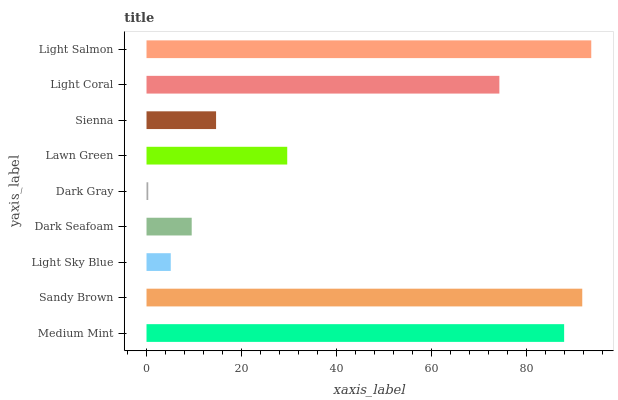Is Dark Gray the minimum?
Answer yes or no. Yes. Is Light Salmon the maximum?
Answer yes or no. Yes. Is Sandy Brown the minimum?
Answer yes or no. No. Is Sandy Brown the maximum?
Answer yes or no. No. Is Sandy Brown greater than Medium Mint?
Answer yes or no. Yes. Is Medium Mint less than Sandy Brown?
Answer yes or no. Yes. Is Medium Mint greater than Sandy Brown?
Answer yes or no. No. Is Sandy Brown less than Medium Mint?
Answer yes or no. No. Is Lawn Green the high median?
Answer yes or no. Yes. Is Lawn Green the low median?
Answer yes or no. Yes. Is Light Salmon the high median?
Answer yes or no. No. Is Light Sky Blue the low median?
Answer yes or no. No. 